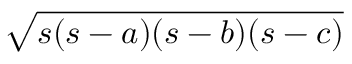<formula> <loc_0><loc_0><loc_500><loc_500>{ \sqrt { s ( s - a ) ( s - b ) ( s - c ) } } \,</formula> 